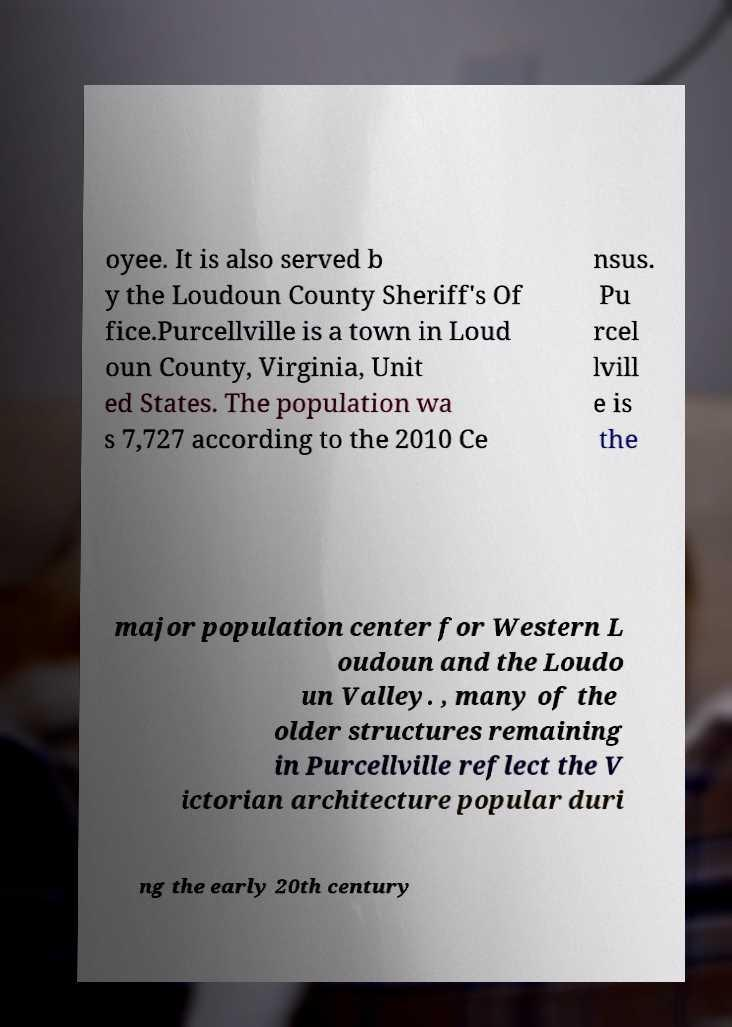What messages or text are displayed in this image? I need them in a readable, typed format. oyee. It is also served b y the Loudoun County Sheriff's Of fice.Purcellville is a town in Loud oun County, Virginia, Unit ed States. The population wa s 7,727 according to the 2010 Ce nsus. Pu rcel lvill e is the major population center for Western L oudoun and the Loudo un Valley. , many of the older structures remaining in Purcellville reflect the V ictorian architecture popular duri ng the early 20th century 